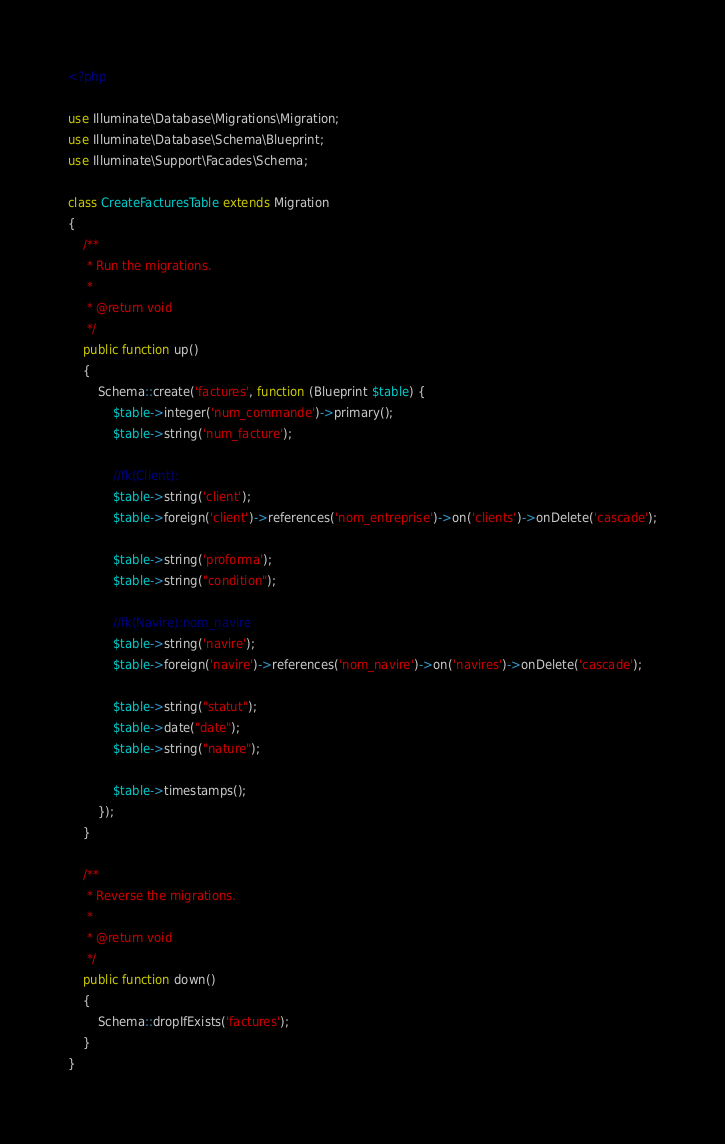<code> <loc_0><loc_0><loc_500><loc_500><_PHP_><?php

use Illuminate\Database\Migrations\Migration;
use Illuminate\Database\Schema\Blueprint;
use Illuminate\Support\Facades\Schema;

class CreateFacturesTable extends Migration
{
    /**
     * Run the migrations.
     *
     * @return void
     */
    public function up()
    {
        Schema::create('factures', function (Blueprint $table) {
            $table->integer('num_commande')->primary();
            $table->string('num_facture');

            //fk(Client):
            $table->string('client');
            $table->foreign('client')->references('nom_entreprise')->on('clients')->onDelete('cascade');

            $table->string('proforma');
            $table->string("condition");

            //fk(Navire):nom_navire
            $table->string('navire');
            $table->foreign('navire')->references('nom_navire')->on('navires')->onDelete('cascade');

            $table->string("statut");
            $table->date("date");
            $table->string("nature");

            $table->timestamps();
        });
    }

    /**
     * Reverse the migrations.
     *
     * @return void
     */
    public function down()
    {
        Schema::dropIfExists('factures');
    }
}
</code> 